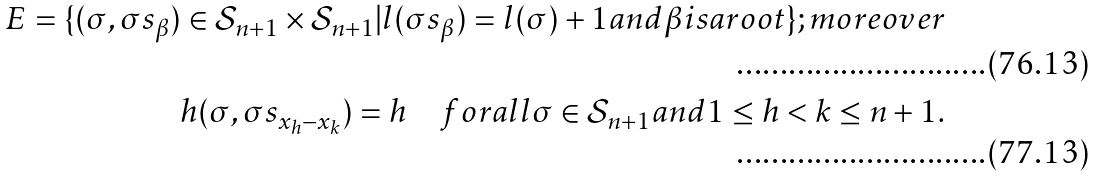Convert formula to latex. <formula><loc_0><loc_0><loc_500><loc_500>E = \{ ( \sigma , \sigma s _ { \beta } ) \in \mathcal { S } _ { n + 1 } \times \mathcal { S } _ { n + 1 } | l ( \sigma s _ { \beta } ) = l ( \sigma ) + 1 a n d \beta i s a r o o t \} ; m o r e o v e r \\ h ( \sigma , \sigma s _ { x _ { h } - x _ { k } } ) = h \quad f o r a l l \sigma \in \mathcal { S } _ { n + 1 } a n d 1 \leq h < k \leq n + 1 .</formula> 